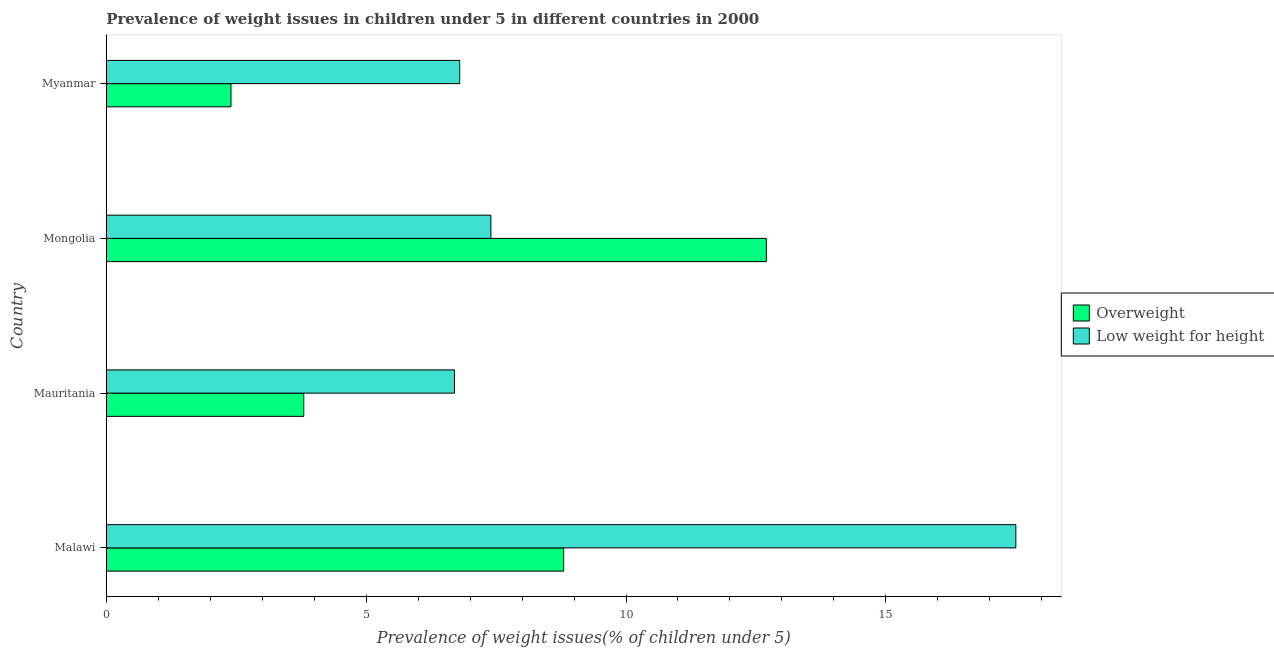How many groups of bars are there?
Offer a very short reply. 4. Are the number of bars per tick equal to the number of legend labels?
Ensure brevity in your answer.  Yes. What is the label of the 1st group of bars from the top?
Make the answer very short. Myanmar. In how many cases, is the number of bars for a given country not equal to the number of legend labels?
Provide a short and direct response. 0. What is the percentage of overweight children in Malawi?
Your response must be concise. 8.8. Across all countries, what is the minimum percentage of underweight children?
Your response must be concise. 6.7. In which country was the percentage of overweight children maximum?
Provide a short and direct response. Mongolia. In which country was the percentage of underweight children minimum?
Make the answer very short. Mauritania. What is the total percentage of underweight children in the graph?
Provide a short and direct response. 38.4. What is the difference between the percentage of overweight children in Mongolia and the percentage of underweight children in Mauritania?
Offer a very short reply. 6. What is the average percentage of underweight children per country?
Your response must be concise. 9.6. What is the difference between the percentage of underweight children and percentage of overweight children in Malawi?
Your answer should be very brief. 8.7. Is the difference between the percentage of overweight children in Mauritania and Myanmar greater than the difference between the percentage of underweight children in Mauritania and Myanmar?
Your answer should be compact. Yes. What is the difference between the highest and the second highest percentage of overweight children?
Keep it short and to the point. 3.9. What is the difference between the highest and the lowest percentage of underweight children?
Your response must be concise. 10.8. What does the 2nd bar from the top in Mongolia represents?
Keep it short and to the point. Overweight. What does the 2nd bar from the bottom in Malawi represents?
Make the answer very short. Low weight for height. What is the difference between two consecutive major ticks on the X-axis?
Offer a very short reply. 5. Are the values on the major ticks of X-axis written in scientific E-notation?
Give a very brief answer. No. How many legend labels are there?
Provide a short and direct response. 2. How are the legend labels stacked?
Offer a terse response. Vertical. What is the title of the graph?
Make the answer very short. Prevalence of weight issues in children under 5 in different countries in 2000. Does "Highest 10% of population" appear as one of the legend labels in the graph?
Provide a short and direct response. No. What is the label or title of the X-axis?
Give a very brief answer. Prevalence of weight issues(% of children under 5). What is the Prevalence of weight issues(% of children under 5) of Overweight in Malawi?
Offer a very short reply. 8.8. What is the Prevalence of weight issues(% of children under 5) of Low weight for height in Malawi?
Offer a very short reply. 17.5. What is the Prevalence of weight issues(% of children under 5) of Overweight in Mauritania?
Give a very brief answer. 3.8. What is the Prevalence of weight issues(% of children under 5) of Low weight for height in Mauritania?
Provide a short and direct response. 6.7. What is the Prevalence of weight issues(% of children under 5) of Overweight in Mongolia?
Make the answer very short. 12.7. What is the Prevalence of weight issues(% of children under 5) in Low weight for height in Mongolia?
Your answer should be compact. 7.4. What is the Prevalence of weight issues(% of children under 5) in Overweight in Myanmar?
Your response must be concise. 2.4. What is the Prevalence of weight issues(% of children under 5) of Low weight for height in Myanmar?
Offer a terse response. 6.8. Across all countries, what is the maximum Prevalence of weight issues(% of children under 5) of Overweight?
Offer a terse response. 12.7. Across all countries, what is the minimum Prevalence of weight issues(% of children under 5) of Overweight?
Your response must be concise. 2.4. Across all countries, what is the minimum Prevalence of weight issues(% of children under 5) in Low weight for height?
Provide a short and direct response. 6.7. What is the total Prevalence of weight issues(% of children under 5) in Overweight in the graph?
Give a very brief answer. 27.7. What is the total Prevalence of weight issues(% of children under 5) of Low weight for height in the graph?
Your response must be concise. 38.4. What is the difference between the Prevalence of weight issues(% of children under 5) in Low weight for height in Malawi and that in Mauritania?
Offer a very short reply. 10.8. What is the difference between the Prevalence of weight issues(% of children under 5) of Overweight in Malawi and that in Mongolia?
Your answer should be compact. -3.9. What is the difference between the Prevalence of weight issues(% of children under 5) of Low weight for height in Malawi and that in Myanmar?
Your answer should be very brief. 10.7. What is the difference between the Prevalence of weight issues(% of children under 5) of Low weight for height in Mauritania and that in Mongolia?
Offer a terse response. -0.7. What is the difference between the Prevalence of weight issues(% of children under 5) of Overweight in Mauritania and that in Myanmar?
Offer a very short reply. 1.4. What is the difference between the Prevalence of weight issues(% of children under 5) of Overweight in Mongolia and that in Myanmar?
Make the answer very short. 10.3. What is the difference between the Prevalence of weight issues(% of children under 5) in Low weight for height in Mongolia and that in Myanmar?
Give a very brief answer. 0.6. What is the difference between the Prevalence of weight issues(% of children under 5) in Overweight in Malawi and the Prevalence of weight issues(% of children under 5) in Low weight for height in Mauritania?
Your answer should be very brief. 2.1. What is the average Prevalence of weight issues(% of children under 5) of Overweight per country?
Your answer should be compact. 6.92. What is the difference between the Prevalence of weight issues(% of children under 5) in Overweight and Prevalence of weight issues(% of children under 5) in Low weight for height in Malawi?
Your response must be concise. -8.7. What is the difference between the Prevalence of weight issues(% of children under 5) of Overweight and Prevalence of weight issues(% of children under 5) of Low weight for height in Mauritania?
Offer a very short reply. -2.9. What is the ratio of the Prevalence of weight issues(% of children under 5) of Overweight in Malawi to that in Mauritania?
Ensure brevity in your answer.  2.32. What is the ratio of the Prevalence of weight issues(% of children under 5) of Low weight for height in Malawi to that in Mauritania?
Your response must be concise. 2.61. What is the ratio of the Prevalence of weight issues(% of children under 5) in Overweight in Malawi to that in Mongolia?
Your response must be concise. 0.69. What is the ratio of the Prevalence of weight issues(% of children under 5) of Low weight for height in Malawi to that in Mongolia?
Offer a terse response. 2.36. What is the ratio of the Prevalence of weight issues(% of children under 5) in Overweight in Malawi to that in Myanmar?
Offer a very short reply. 3.67. What is the ratio of the Prevalence of weight issues(% of children under 5) in Low weight for height in Malawi to that in Myanmar?
Your answer should be very brief. 2.57. What is the ratio of the Prevalence of weight issues(% of children under 5) in Overweight in Mauritania to that in Mongolia?
Provide a succinct answer. 0.3. What is the ratio of the Prevalence of weight issues(% of children under 5) in Low weight for height in Mauritania to that in Mongolia?
Make the answer very short. 0.91. What is the ratio of the Prevalence of weight issues(% of children under 5) in Overweight in Mauritania to that in Myanmar?
Ensure brevity in your answer.  1.58. What is the ratio of the Prevalence of weight issues(% of children under 5) of Low weight for height in Mauritania to that in Myanmar?
Make the answer very short. 0.99. What is the ratio of the Prevalence of weight issues(% of children under 5) in Overweight in Mongolia to that in Myanmar?
Your response must be concise. 5.29. What is the ratio of the Prevalence of weight issues(% of children under 5) of Low weight for height in Mongolia to that in Myanmar?
Your answer should be compact. 1.09. What is the difference between the highest and the second highest Prevalence of weight issues(% of children under 5) of Overweight?
Offer a very short reply. 3.9. 